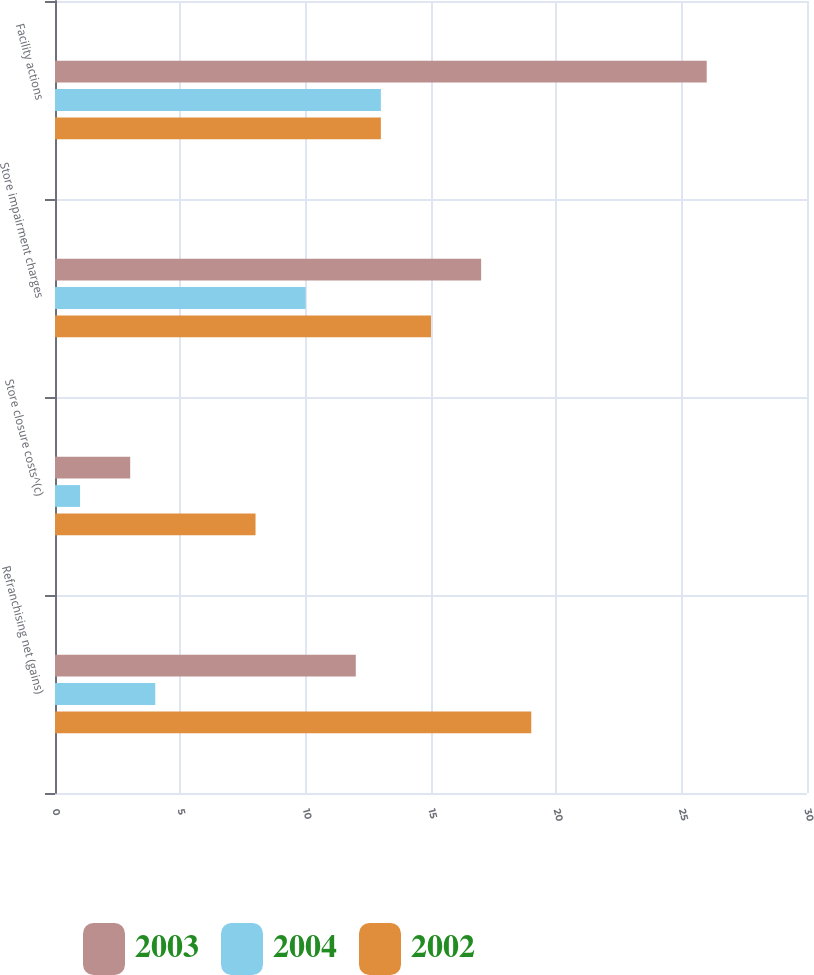Convert chart. <chart><loc_0><loc_0><loc_500><loc_500><stacked_bar_chart><ecel><fcel>Refranchising net (gains)<fcel>Store closure costs^(c)<fcel>Store impairment charges<fcel>Facility actions<nl><fcel>2003<fcel>12<fcel>3<fcel>17<fcel>26<nl><fcel>2004<fcel>4<fcel>1<fcel>10<fcel>13<nl><fcel>2002<fcel>19<fcel>8<fcel>15<fcel>13<nl></chart> 